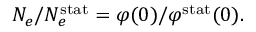<formula> <loc_0><loc_0><loc_500><loc_500>N _ { e } / N _ { e } ^ { s t a t } = \varphi ( 0 ) / \varphi ^ { s t a t } ( 0 ) .</formula> 